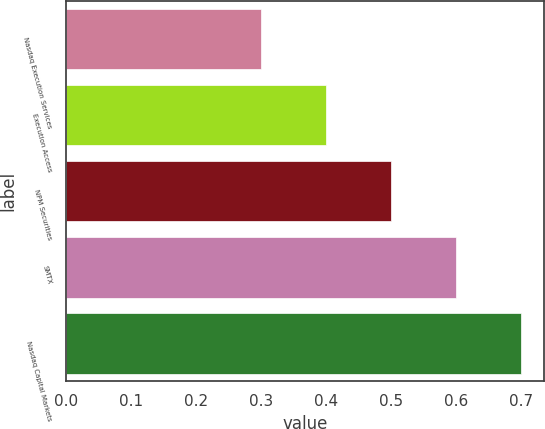Convert chart to OTSL. <chart><loc_0><loc_0><loc_500><loc_500><bar_chart><fcel>Nasdaq Execution Services<fcel>Execution Access<fcel>NPM Securities<fcel>SMTX<fcel>Nasdaq Capital Markets<nl><fcel>0.3<fcel>0.4<fcel>0.5<fcel>0.6<fcel>0.7<nl></chart> 